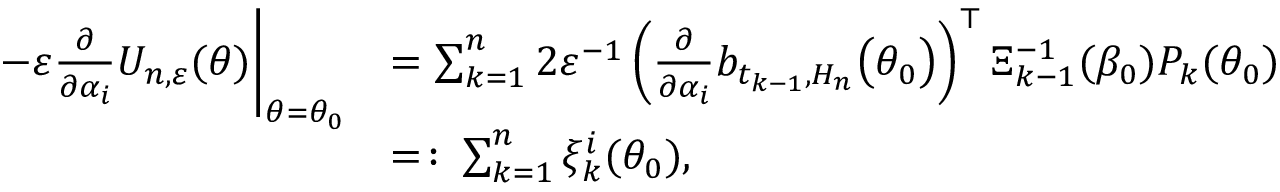<formula> <loc_0><loc_0><loc_500><loc_500>\begin{array} { r l } { - \varepsilon \frac { \partial } { \partial \alpha _ { i } } U _ { n , \varepsilon } ( \theta ) \Big | _ { \theta = \theta _ { 0 } } } & { = \sum _ { k = 1 } ^ { n } 2 \varepsilon ^ { - 1 } \left ( \frac { \partial } { \partial \alpha _ { i } } b _ { t _ { k - 1 } , H _ { n } } \Big ( \theta _ { 0 } \Big ) \right ) ^ { \top } \Xi _ { k - 1 } ^ { - 1 } ( \beta _ { 0 } ) P _ { k } ( \theta _ { 0 } ) } \\ & { = \colon \sum _ { k = 1 } ^ { n } \xi _ { k } ^ { i } ( \theta _ { 0 } ) , } \end{array}</formula> 